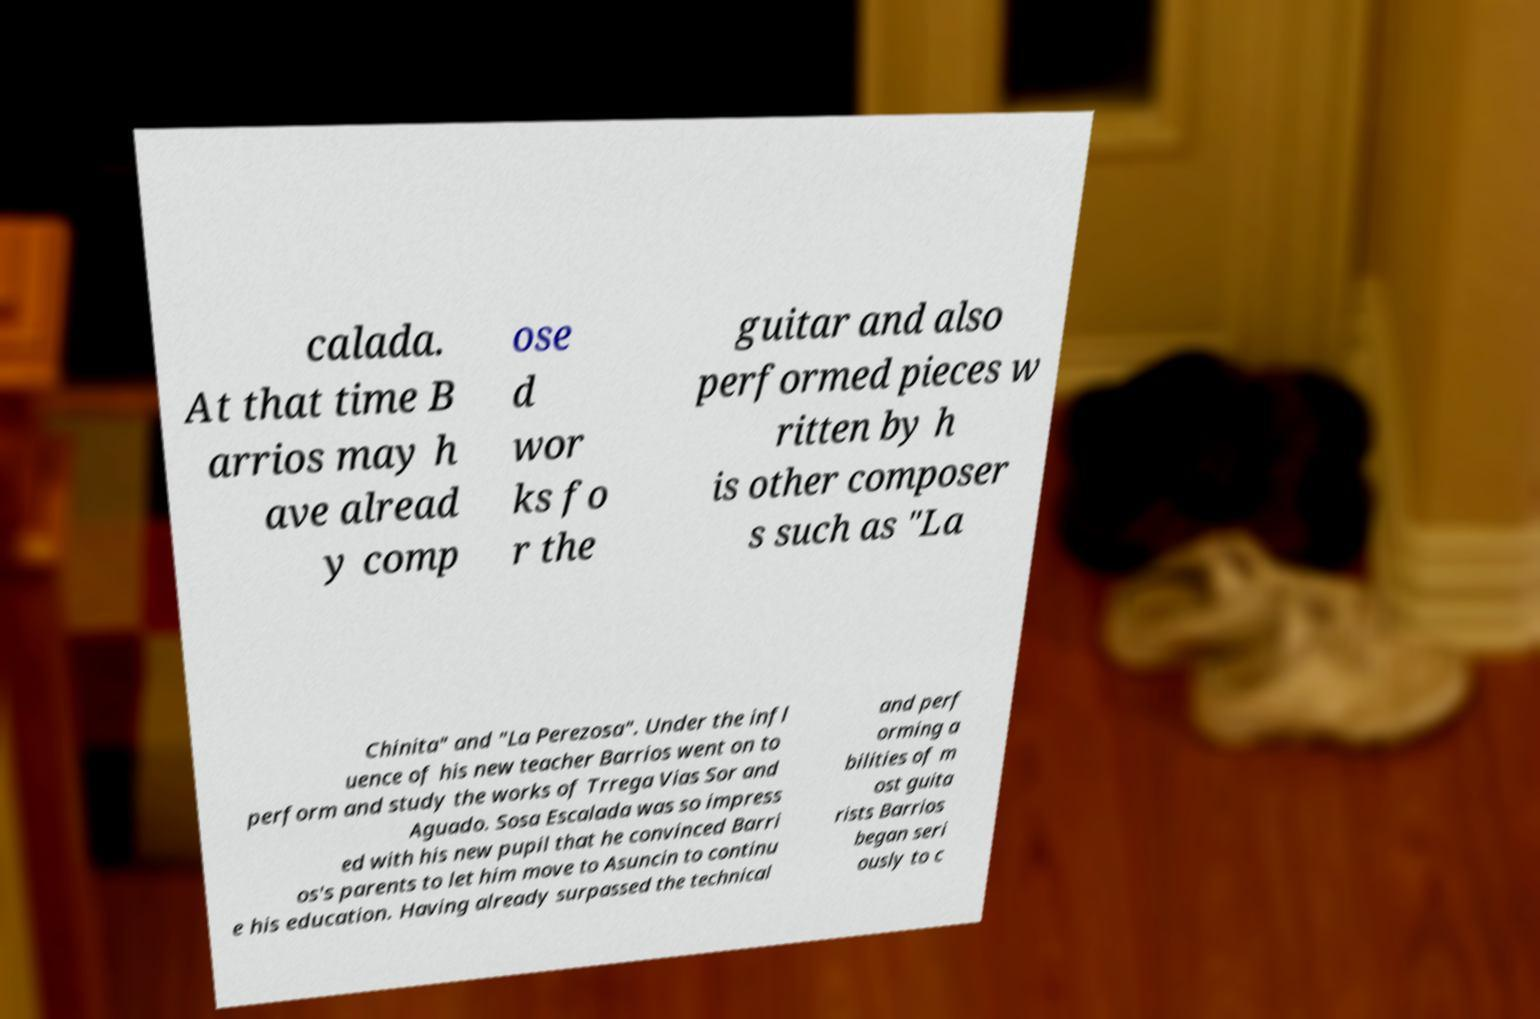Please read and relay the text visible in this image. What does it say? calada. At that time B arrios may h ave alread y comp ose d wor ks fo r the guitar and also performed pieces w ritten by h is other composer s such as "La Chinita" and "La Perezosa". Under the infl uence of his new teacher Barrios went on to perform and study the works of Trrega Vias Sor and Aguado. Sosa Escalada was so impress ed with his new pupil that he convinced Barri os's parents to let him move to Asuncin to continu e his education. Having already surpassed the technical and perf orming a bilities of m ost guita rists Barrios began seri ously to c 